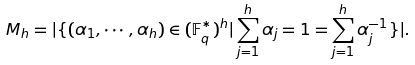<formula> <loc_0><loc_0><loc_500><loc_500>M _ { h } = | \{ ( \alpha _ { 1 } , \cdots , \alpha _ { h } ) \in ( \mathbb { F } _ { q } ^ { * } ) ^ { h } | \sum _ { j = 1 } ^ { h } \alpha _ { j } = 1 = \sum _ { j = 1 } ^ { h } \alpha _ { j } ^ { - 1 } \} | .</formula> 